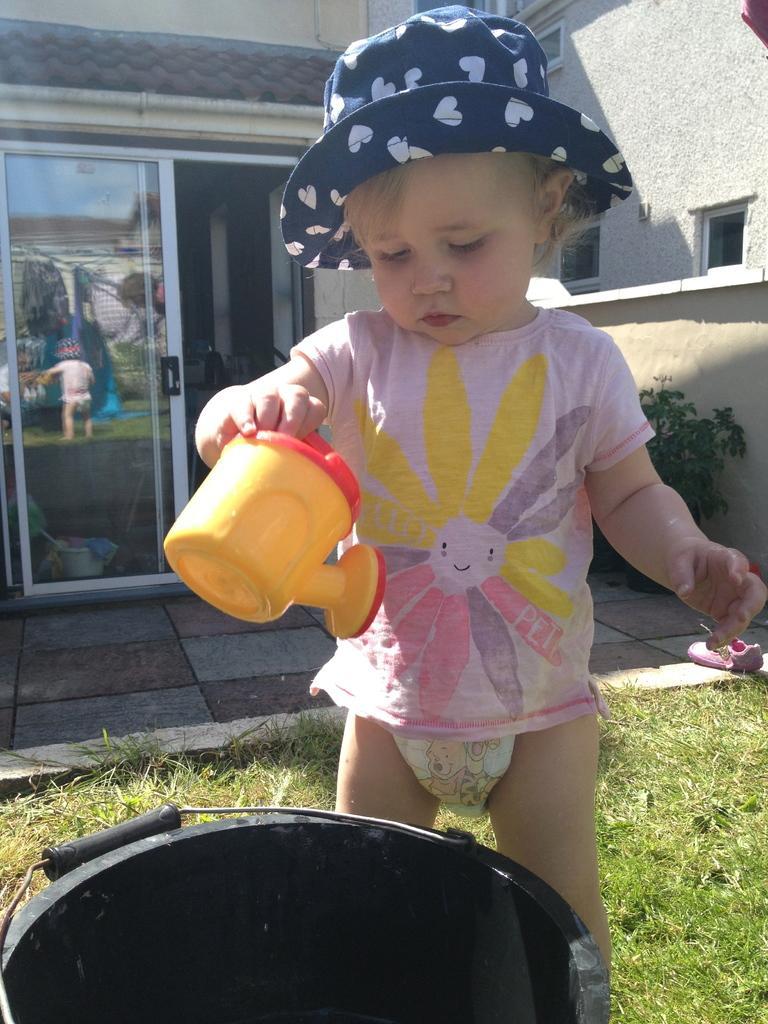Could you give a brief overview of what you see in this image? In this image, we can see a kid wearing a hat and holding an object. In the background, there are buildings and we can see windows and glass doors and plants. At the bottom, we can see a bucket and there is a floor and a ground. 